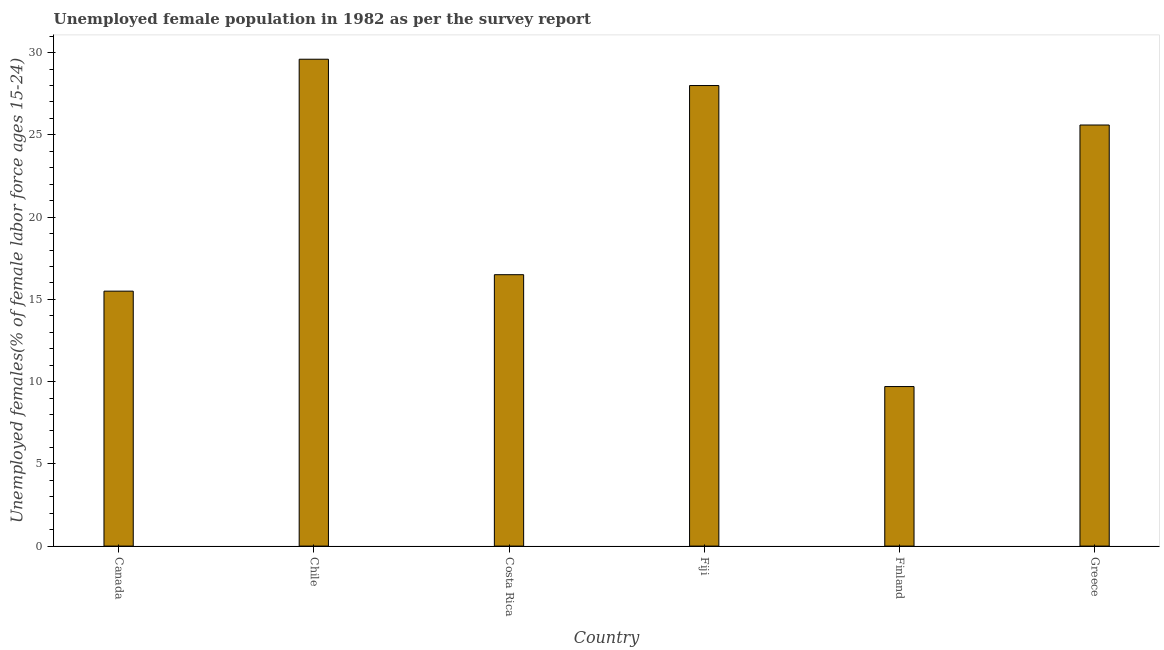Does the graph contain any zero values?
Offer a terse response. No. What is the title of the graph?
Provide a succinct answer. Unemployed female population in 1982 as per the survey report. What is the label or title of the Y-axis?
Provide a succinct answer. Unemployed females(% of female labor force ages 15-24). What is the unemployed female youth in Fiji?
Offer a very short reply. 28. Across all countries, what is the maximum unemployed female youth?
Your response must be concise. 29.6. Across all countries, what is the minimum unemployed female youth?
Make the answer very short. 9.7. In which country was the unemployed female youth maximum?
Make the answer very short. Chile. What is the sum of the unemployed female youth?
Provide a short and direct response. 124.9. What is the average unemployed female youth per country?
Offer a terse response. 20.82. What is the median unemployed female youth?
Give a very brief answer. 21.05. In how many countries, is the unemployed female youth greater than 13 %?
Make the answer very short. 5. What is the ratio of the unemployed female youth in Costa Rica to that in Finland?
Provide a succinct answer. 1.7. Is the unemployed female youth in Chile less than that in Costa Rica?
Provide a short and direct response. No. Is the difference between the unemployed female youth in Chile and Greece greater than the difference between any two countries?
Offer a terse response. No. In how many countries, is the unemployed female youth greater than the average unemployed female youth taken over all countries?
Your response must be concise. 3. How many bars are there?
Ensure brevity in your answer.  6. Are all the bars in the graph horizontal?
Give a very brief answer. No. How many countries are there in the graph?
Offer a very short reply. 6. Are the values on the major ticks of Y-axis written in scientific E-notation?
Provide a short and direct response. No. What is the Unemployed females(% of female labor force ages 15-24) in Chile?
Your response must be concise. 29.6. What is the Unemployed females(% of female labor force ages 15-24) in Costa Rica?
Your answer should be compact. 16.5. What is the Unemployed females(% of female labor force ages 15-24) of Fiji?
Keep it short and to the point. 28. What is the Unemployed females(% of female labor force ages 15-24) of Finland?
Give a very brief answer. 9.7. What is the Unemployed females(% of female labor force ages 15-24) of Greece?
Make the answer very short. 25.6. What is the difference between the Unemployed females(% of female labor force ages 15-24) in Canada and Chile?
Keep it short and to the point. -14.1. What is the difference between the Unemployed females(% of female labor force ages 15-24) in Canada and Finland?
Make the answer very short. 5.8. What is the difference between the Unemployed females(% of female labor force ages 15-24) in Canada and Greece?
Make the answer very short. -10.1. What is the difference between the Unemployed females(% of female labor force ages 15-24) in Chile and Costa Rica?
Give a very brief answer. 13.1. What is the difference between the Unemployed females(% of female labor force ages 15-24) in Chile and Fiji?
Ensure brevity in your answer.  1.6. What is the difference between the Unemployed females(% of female labor force ages 15-24) in Chile and Finland?
Your answer should be compact. 19.9. What is the difference between the Unemployed females(% of female labor force ages 15-24) in Costa Rica and Fiji?
Ensure brevity in your answer.  -11.5. What is the difference between the Unemployed females(% of female labor force ages 15-24) in Fiji and Greece?
Offer a very short reply. 2.4. What is the difference between the Unemployed females(% of female labor force ages 15-24) in Finland and Greece?
Offer a terse response. -15.9. What is the ratio of the Unemployed females(% of female labor force ages 15-24) in Canada to that in Chile?
Ensure brevity in your answer.  0.52. What is the ratio of the Unemployed females(% of female labor force ages 15-24) in Canada to that in Costa Rica?
Provide a succinct answer. 0.94. What is the ratio of the Unemployed females(% of female labor force ages 15-24) in Canada to that in Fiji?
Your answer should be compact. 0.55. What is the ratio of the Unemployed females(% of female labor force ages 15-24) in Canada to that in Finland?
Your answer should be compact. 1.6. What is the ratio of the Unemployed females(% of female labor force ages 15-24) in Canada to that in Greece?
Your response must be concise. 0.6. What is the ratio of the Unemployed females(% of female labor force ages 15-24) in Chile to that in Costa Rica?
Keep it short and to the point. 1.79. What is the ratio of the Unemployed females(% of female labor force ages 15-24) in Chile to that in Fiji?
Make the answer very short. 1.06. What is the ratio of the Unemployed females(% of female labor force ages 15-24) in Chile to that in Finland?
Your response must be concise. 3.05. What is the ratio of the Unemployed females(% of female labor force ages 15-24) in Chile to that in Greece?
Make the answer very short. 1.16. What is the ratio of the Unemployed females(% of female labor force ages 15-24) in Costa Rica to that in Fiji?
Ensure brevity in your answer.  0.59. What is the ratio of the Unemployed females(% of female labor force ages 15-24) in Costa Rica to that in Finland?
Your response must be concise. 1.7. What is the ratio of the Unemployed females(% of female labor force ages 15-24) in Costa Rica to that in Greece?
Your answer should be compact. 0.65. What is the ratio of the Unemployed females(% of female labor force ages 15-24) in Fiji to that in Finland?
Your answer should be very brief. 2.89. What is the ratio of the Unemployed females(% of female labor force ages 15-24) in Fiji to that in Greece?
Give a very brief answer. 1.09. What is the ratio of the Unemployed females(% of female labor force ages 15-24) in Finland to that in Greece?
Provide a succinct answer. 0.38. 